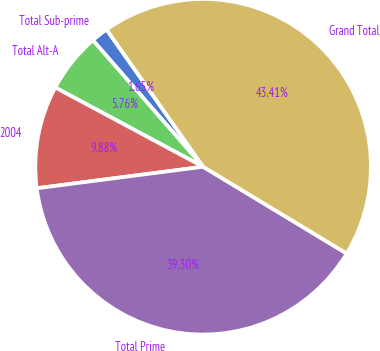Convert chart. <chart><loc_0><loc_0><loc_500><loc_500><pie_chart><fcel>Total Sub-prime<fcel>Total Alt-A<fcel>2004<fcel>Total Prime<fcel>Grand Total<nl><fcel>1.65%<fcel>5.76%<fcel>9.88%<fcel>39.3%<fcel>43.41%<nl></chart> 